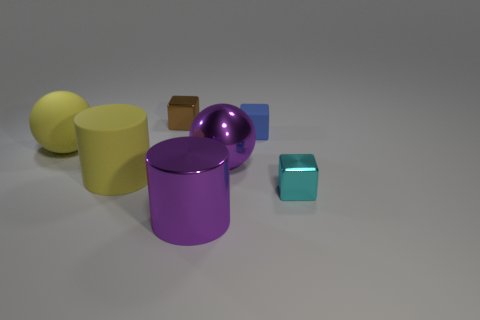Subtract all red balls. Subtract all green blocks. How many balls are left? 2 Add 2 big purple metallic objects. How many objects exist? 9 Subtract all cylinders. How many objects are left? 5 Subtract 0 green balls. How many objects are left? 7 Subtract all big yellow metal cylinders. Subtract all brown shiny blocks. How many objects are left? 6 Add 4 purple objects. How many purple objects are left? 6 Add 1 blue rubber things. How many blue rubber things exist? 2 